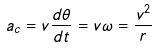Convert formula to latex. <formula><loc_0><loc_0><loc_500><loc_500>a _ { c } = v { \frac { d \theta } { d t } } = v \omega = { \frac { v ^ { 2 } } { r } }</formula> 